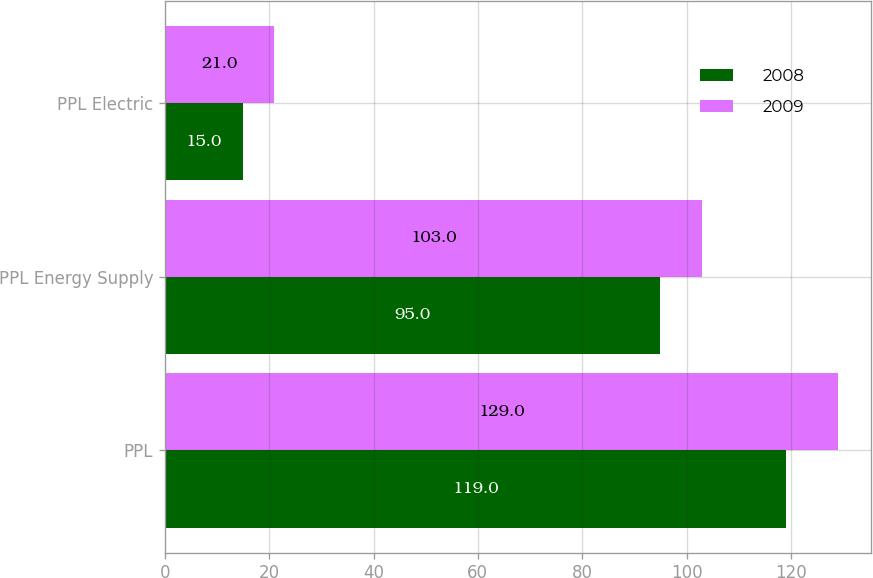<chart> <loc_0><loc_0><loc_500><loc_500><stacked_bar_chart><ecel><fcel>PPL<fcel>PPL Energy Supply<fcel>PPL Electric<nl><fcel>2008<fcel>119<fcel>95<fcel>15<nl><fcel>2009<fcel>129<fcel>103<fcel>21<nl></chart> 